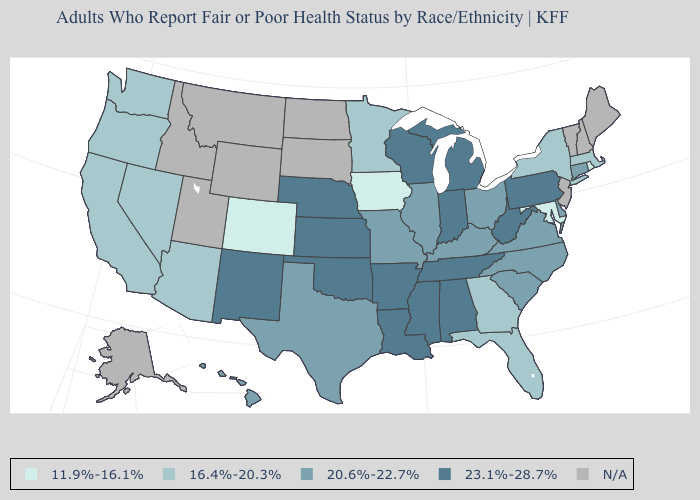What is the lowest value in states that border New Hampshire?
Write a very short answer. 16.4%-20.3%. Name the states that have a value in the range 16.4%-20.3%?
Quick response, please. Arizona, California, Florida, Georgia, Massachusetts, Minnesota, Nevada, New York, Oregon, Washington. What is the value of Texas?
Quick response, please. 20.6%-22.7%. Name the states that have a value in the range 20.6%-22.7%?
Short answer required. Connecticut, Delaware, Hawaii, Illinois, Kentucky, Missouri, North Carolina, Ohio, South Carolina, Texas, Virginia. Is the legend a continuous bar?
Quick response, please. No. Which states have the lowest value in the Northeast?
Keep it brief. Rhode Island. Name the states that have a value in the range 20.6%-22.7%?
Keep it brief. Connecticut, Delaware, Hawaii, Illinois, Kentucky, Missouri, North Carolina, Ohio, South Carolina, Texas, Virginia. Which states have the highest value in the USA?
Be succinct. Alabama, Arkansas, Indiana, Kansas, Louisiana, Michigan, Mississippi, Nebraska, New Mexico, Oklahoma, Pennsylvania, Tennessee, West Virginia, Wisconsin. Name the states that have a value in the range 20.6%-22.7%?
Keep it brief. Connecticut, Delaware, Hawaii, Illinois, Kentucky, Missouri, North Carolina, Ohio, South Carolina, Texas, Virginia. What is the lowest value in states that border Iowa?
Short answer required. 16.4%-20.3%. Name the states that have a value in the range 23.1%-28.7%?
Be succinct. Alabama, Arkansas, Indiana, Kansas, Louisiana, Michigan, Mississippi, Nebraska, New Mexico, Oklahoma, Pennsylvania, Tennessee, West Virginia, Wisconsin. What is the highest value in the Northeast ?
Answer briefly. 23.1%-28.7%. Does Kentucky have the highest value in the USA?
Answer briefly. No. What is the lowest value in the West?
Short answer required. 11.9%-16.1%. 